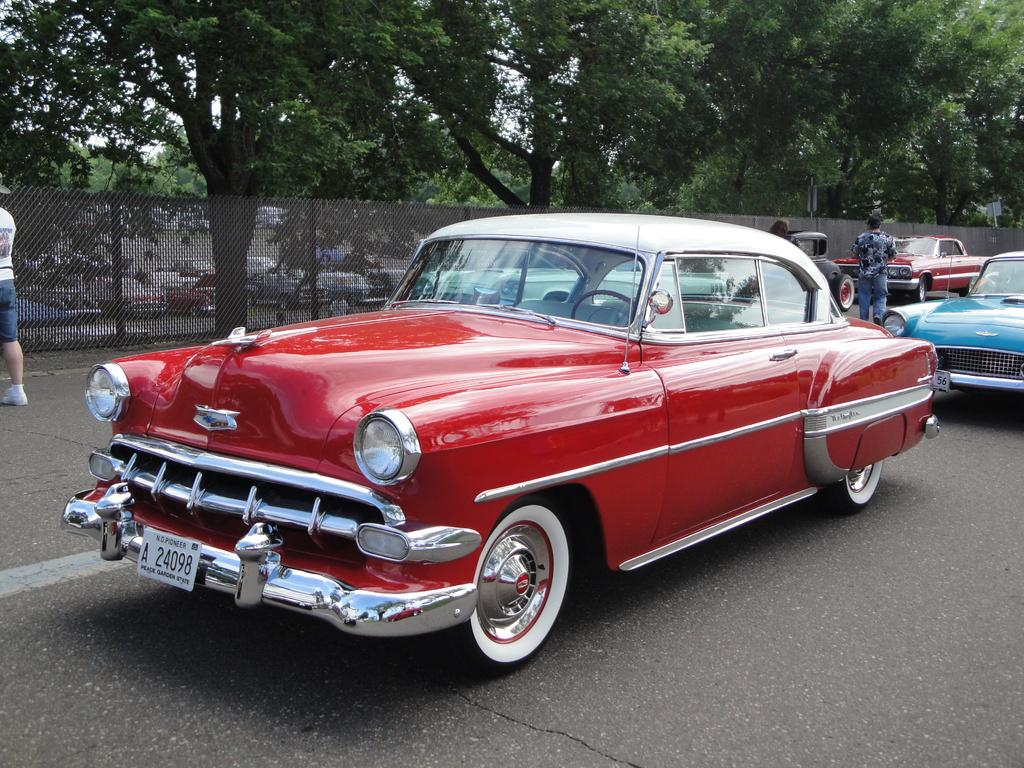What can be seen on the road in the image? There are vehicles and people on the road in the image. What is visible in the background of the image? There is a fence and trees visible in the background of the image. What type of crayon is being used to draw on the engine of the vehicle in the image? There is no crayon or engine present in the image; it features vehicles and people on the road with a background of trees and a fence. 